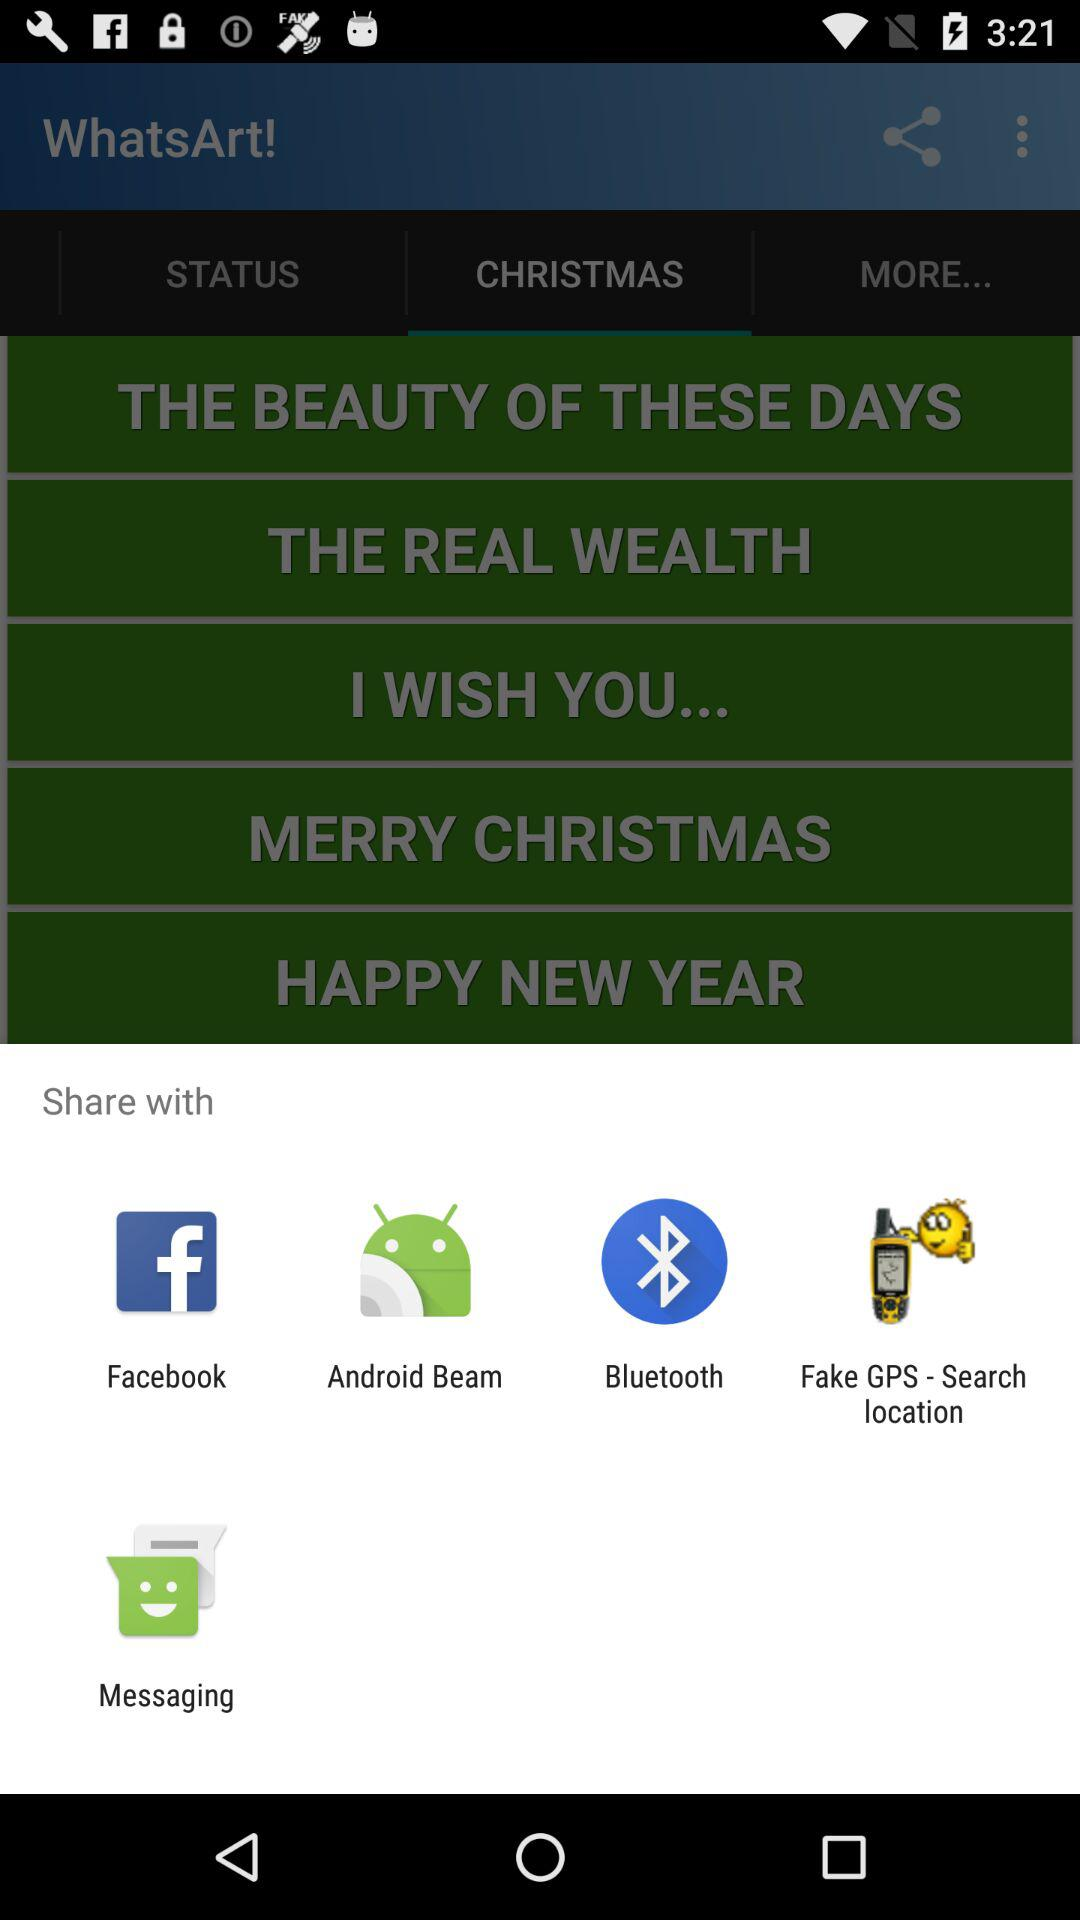What is the name of the application? The name of the application is "WhatsArt!". 